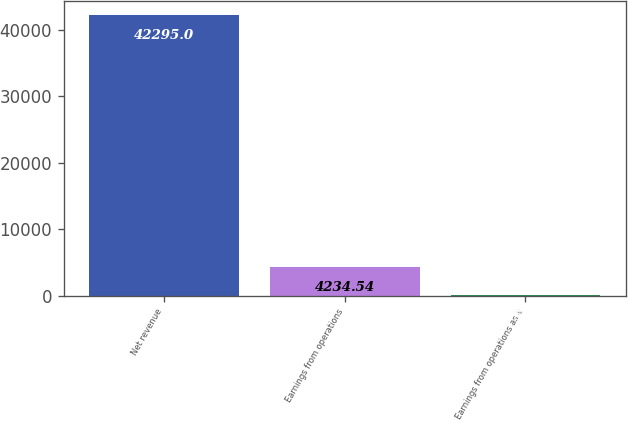Convert chart. <chart><loc_0><loc_0><loc_500><loc_500><bar_chart><fcel>Net revenue<fcel>Earnings from operations<fcel>Earnings from operations as a<nl><fcel>42295<fcel>4234.54<fcel>5.6<nl></chart> 